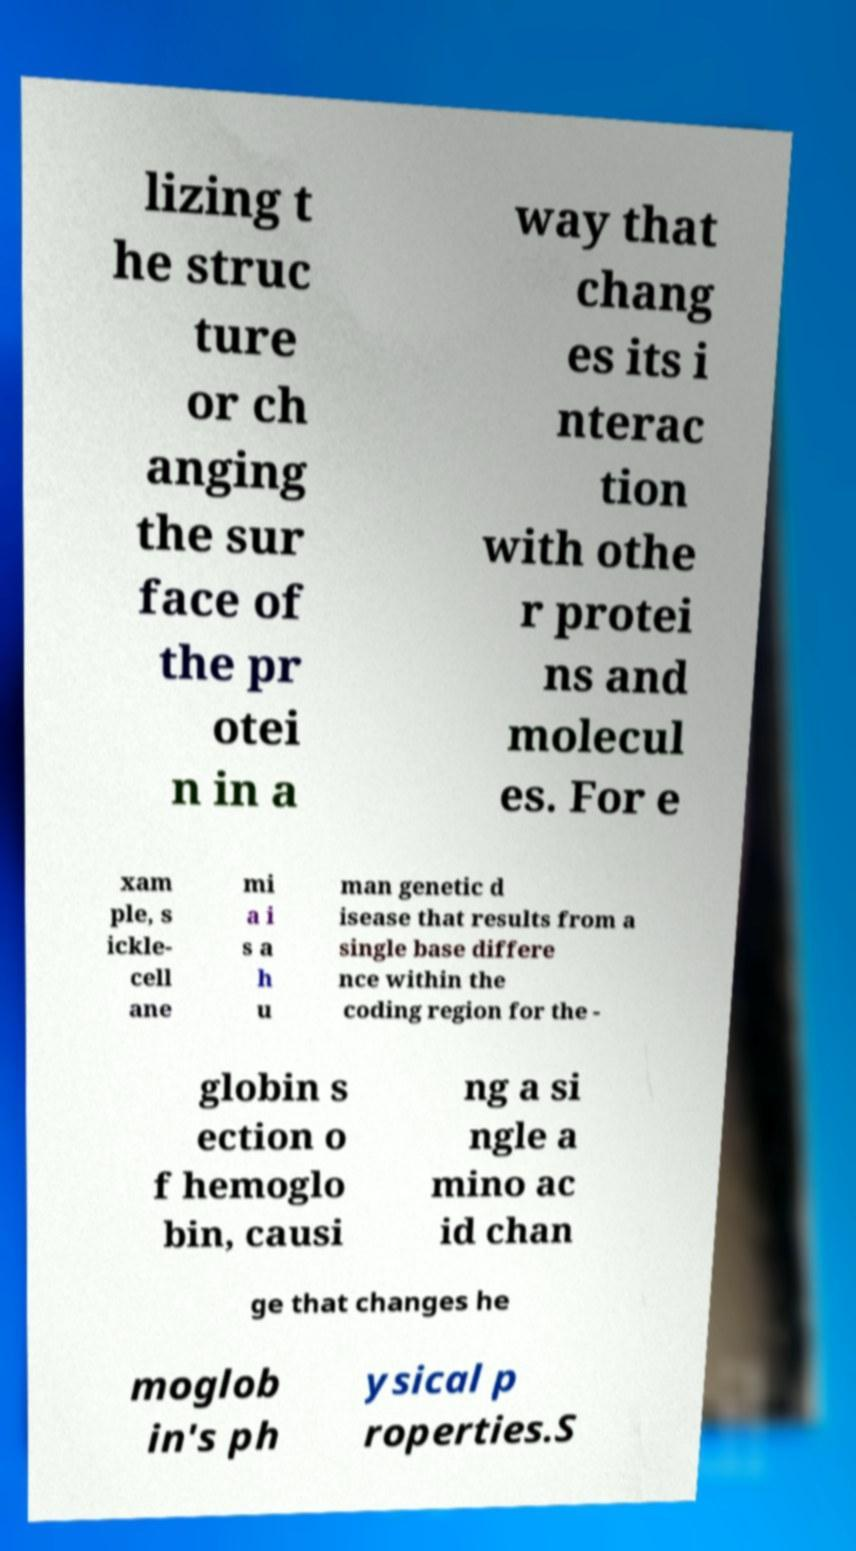Could you extract and type out the text from this image? lizing t he struc ture or ch anging the sur face of the pr otei n in a way that chang es its i nterac tion with othe r protei ns and molecul es. For e xam ple, s ickle- cell ane mi a i s a h u man genetic d isease that results from a single base differe nce within the coding region for the - globin s ection o f hemoglo bin, causi ng a si ngle a mino ac id chan ge that changes he moglob in's ph ysical p roperties.S 